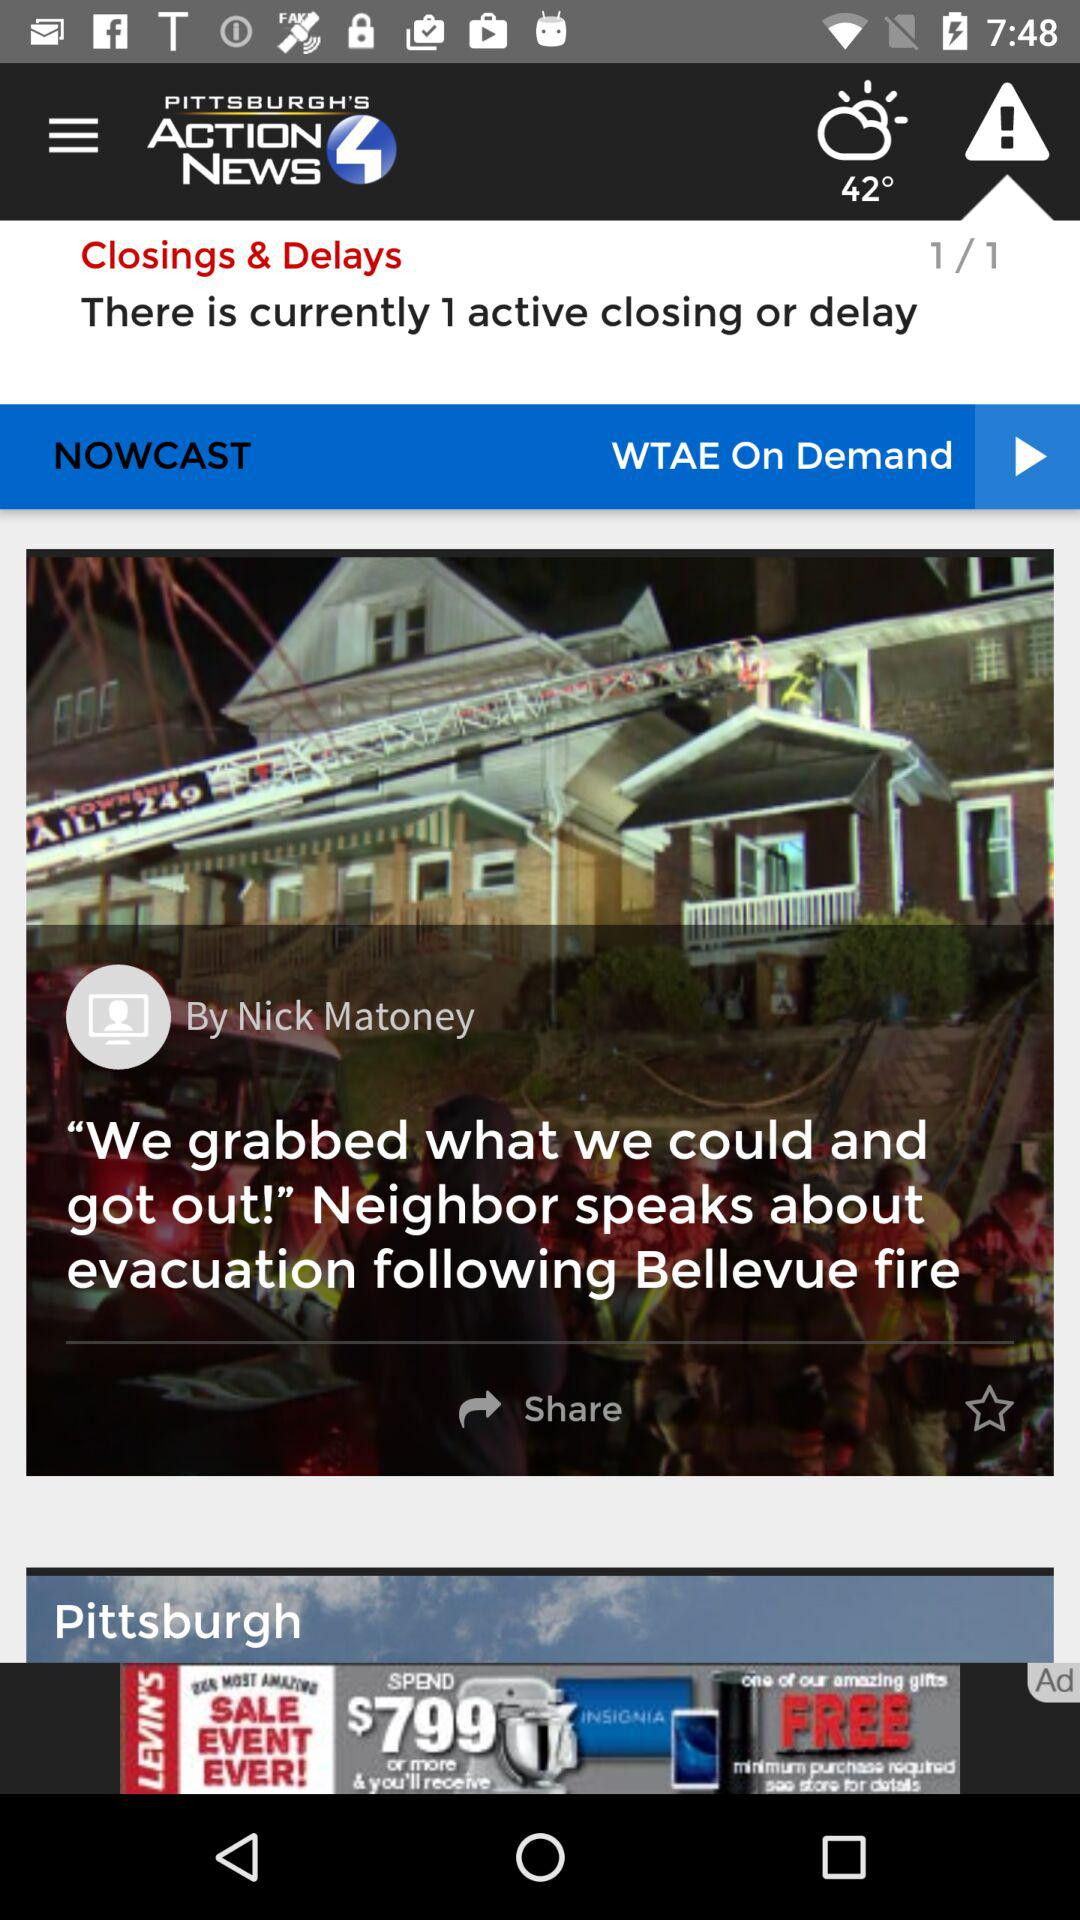What is the application name? The application name is "WTAE- Pittsburgh Action News 4". 